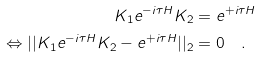Convert formula to latex. <formula><loc_0><loc_0><loc_500><loc_500>K _ { 1 } e ^ { - i \tau H } K _ { 2 } & = e ^ { + i \tau H } \\ \Leftrightarrow | | K _ { 1 } e ^ { - i \tau H } K _ { 2 } - e ^ { + i \tau H } | | _ { 2 } & = 0 \quad .</formula> 